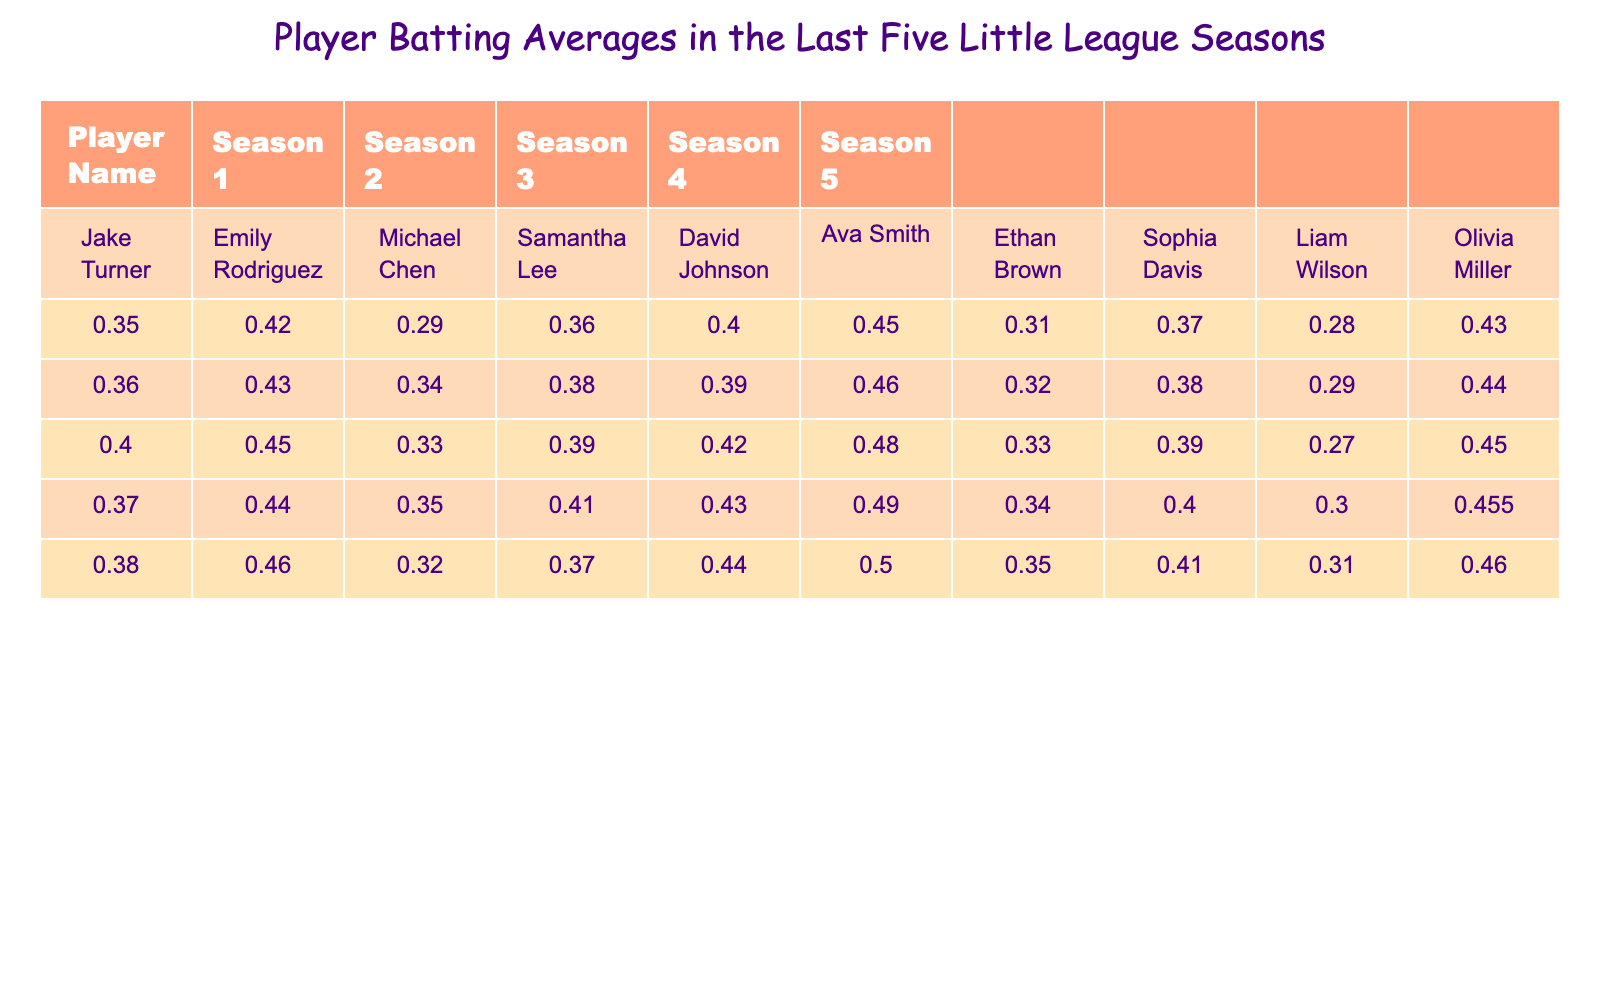What is Emily Rodriguez's batting average in Season 5? Emily Rodriguez's batting average for Season 5 is listed in the corresponding cell under her name, which is 0.460.
Answer: 0.460 Which player had the lowest batting average in Season 3? To find the lowest batting average in Season 3, I compare the averages of all players for that season: Jake Turner (0.400), Emily Rodriguez (0.450), Michael Chen (0.330), Samantha Lee (0.390), David Johnson (0.420), Ava Smith (0.480), Ethan Brown (0.330), Sophia Davis (0.390), Liam Wilson (0.270), and Olivia Miller (0.450). The lowest is Liam Wilson with 0.270.
Answer: Liam Wilson What is the average batting average of Ava Smith over all five seasons? To find the average for Ava Smith, I add her batting averages from all seasons: (0.450 + 0.460 + 0.480 + 0.490 + 0.500) = 2.380. Then I divide by the number of seasons (5): 2.380/5 = 0.476.
Answer: 0.476 Did any player maintain a batting average above 0.400 for all five seasons? I check each player’s averages for each season: Jake Turner (did not), Emily Rodriguez (yes), Michael Chen (did not), Samantha Lee (did not), David Johnson (did not), Ava Smith (yes), Ethan Brown (did not), Sophia Davis (did not), Liam Wilson (did not), Olivia Miller (did not). Thus, Emily Rodriguez and Ava Smith maintained averages above 0.400.
Answer: Yes What was the median batting average for all players in Season 4? First, I list the batting averages for Season 4: 0.370, 0.440, 0.350, 0.410, 0.430, 0.490, 0.340, 0.400, 0.300, 0.455. I then sort these values: 0.300, 0.340, 0.350, 0.370, 0.400, 0.410, 0.430, 0.440, 0.455, 0.490. Since there are 10 values, the median is the average of the 5th and 6th values: (0.400 + 0.410)/2 = 0.405.
Answer: 0.405 